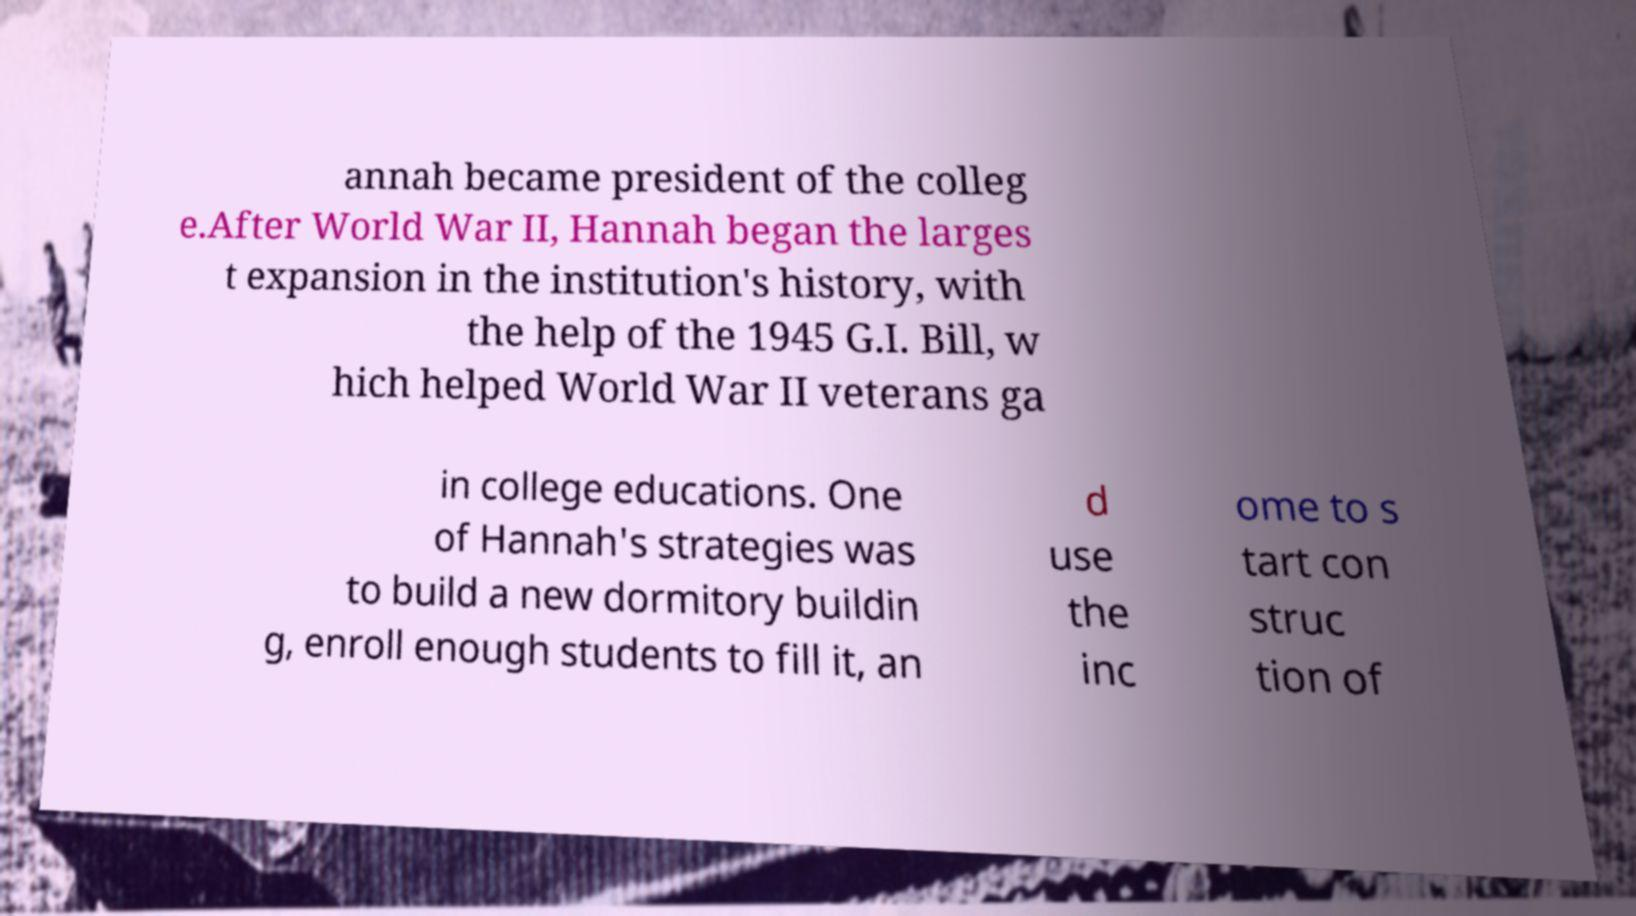Could you assist in decoding the text presented in this image and type it out clearly? annah became president of the colleg e.After World War II, Hannah began the larges t expansion in the institution's history, with the help of the 1945 G.I. Bill, w hich helped World War II veterans ga in college educations. One of Hannah's strategies was to build a new dormitory buildin g, enroll enough students to fill it, an d use the inc ome to s tart con struc tion of 